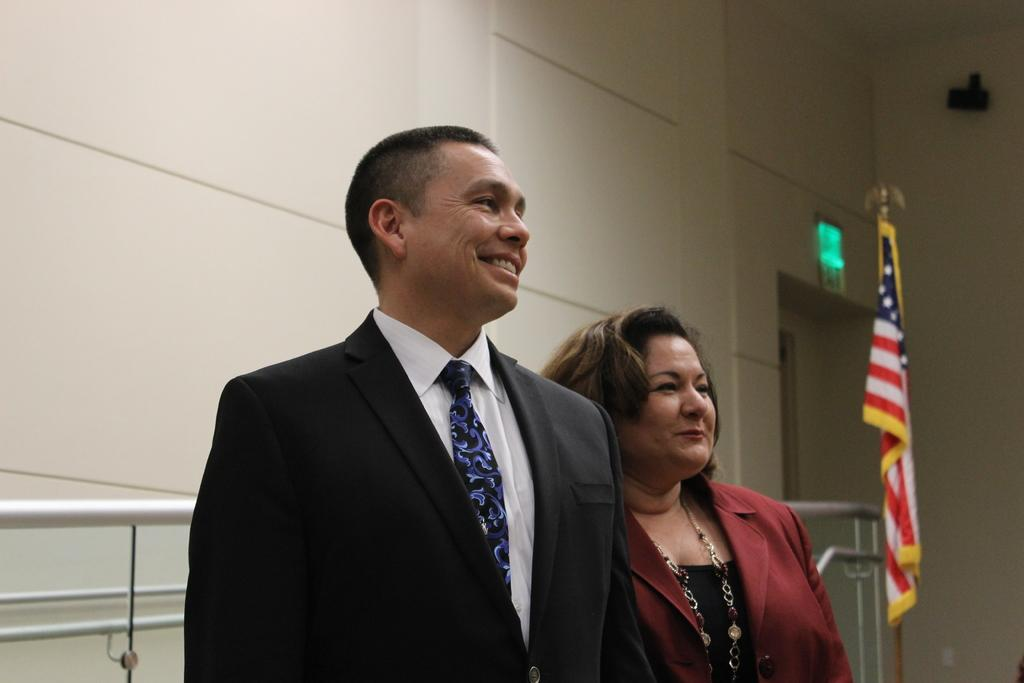How many people are in the image? There are two people in the image. What can be observed about the clothing of the people in the image? The people are wearing different color dresses. What can be seen in the image besides the people? There is a flag visible in the image, and there is a railing and a wall in the background. What type of company is responsible for the earthquake in the image? There is no earthquake present in the image, so it is not possible to determine which company might be responsible. 